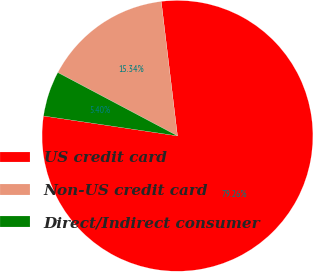Convert chart. <chart><loc_0><loc_0><loc_500><loc_500><pie_chart><fcel>US credit card<fcel>Non-US credit card<fcel>Direct/Indirect consumer<nl><fcel>79.26%<fcel>15.34%<fcel>5.4%<nl></chart> 